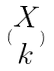<formula> <loc_0><loc_0><loc_500><loc_500>( \begin{matrix} X \\ k \end{matrix} )</formula> 